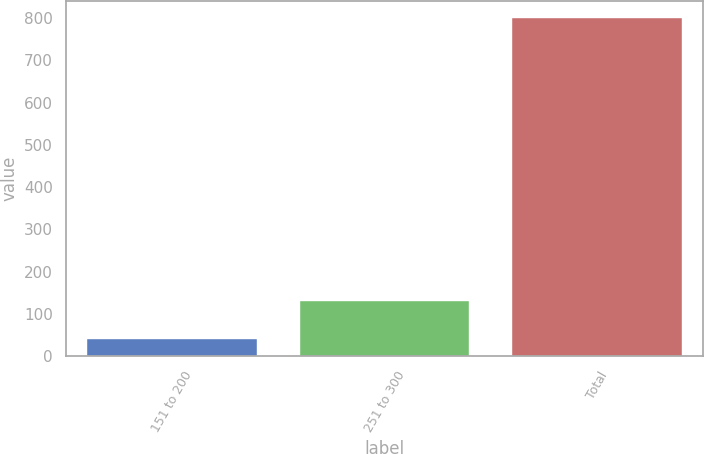Convert chart to OTSL. <chart><loc_0><loc_0><loc_500><loc_500><bar_chart><fcel>151 to 200<fcel>251 to 300<fcel>Total<nl><fcel>40.9<fcel>131.1<fcel>799.7<nl></chart> 